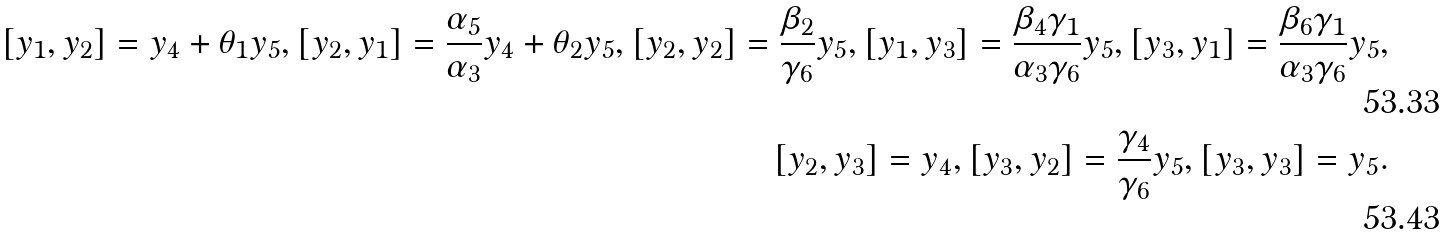Convert formula to latex. <formula><loc_0><loc_0><loc_500><loc_500>[ y _ { 1 } , y _ { 2 } ] = y _ { 4 } + \theta _ { 1 } y _ { 5 } , [ y _ { 2 } , y _ { 1 } ] = \frac { \alpha _ { 5 } } { \alpha _ { 3 } } y _ { 4 } + \theta _ { 2 } y _ { 5 } , [ y _ { 2 } , y _ { 2 } ] = \frac { \beta _ { 2 } } { \gamma _ { 6 } } y _ { 5 } , [ y _ { 1 } , y _ { 3 } ] = \frac { \beta _ { 4 } \gamma _ { 1 } } { \alpha _ { 3 } \gamma _ { 6 } } y _ { 5 } , [ y _ { 3 } , y _ { 1 } ] = \frac { \beta _ { 6 } \gamma _ { 1 } } { \alpha _ { 3 } \gamma _ { 6 } } y _ { 5 } , \\ [ y _ { 2 } , y _ { 3 } ] = y _ { 4 } , [ y _ { 3 } , y _ { 2 } ] = \frac { \gamma _ { 4 } } { \gamma _ { 6 } } y _ { 5 } , [ y _ { 3 } , y _ { 3 } ] = y _ { 5 } .</formula> 